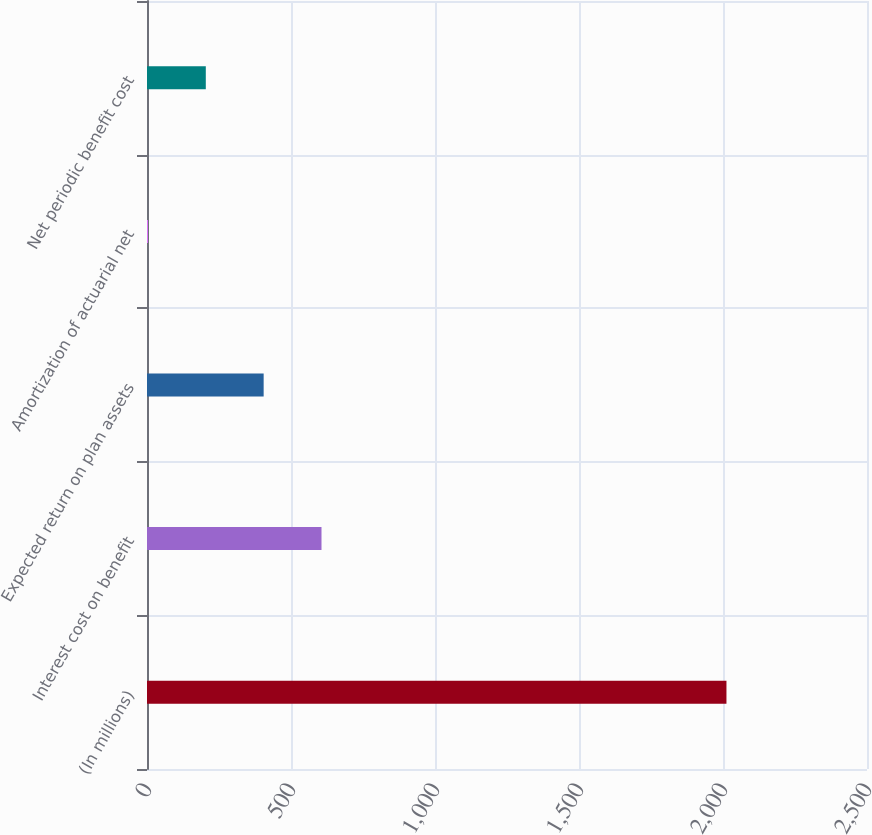Convert chart to OTSL. <chart><loc_0><loc_0><loc_500><loc_500><bar_chart><fcel>(In millions)<fcel>Interest cost on benefit<fcel>Expected return on plan assets<fcel>Amortization of actuarial net<fcel>Net periodic benefit cost<nl><fcel>2012<fcel>605.91<fcel>405.04<fcel>3.3<fcel>204.17<nl></chart> 